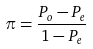<formula> <loc_0><loc_0><loc_500><loc_500>\pi = \frac { P _ { o } - P _ { e } } { 1 - P _ { e } }</formula> 